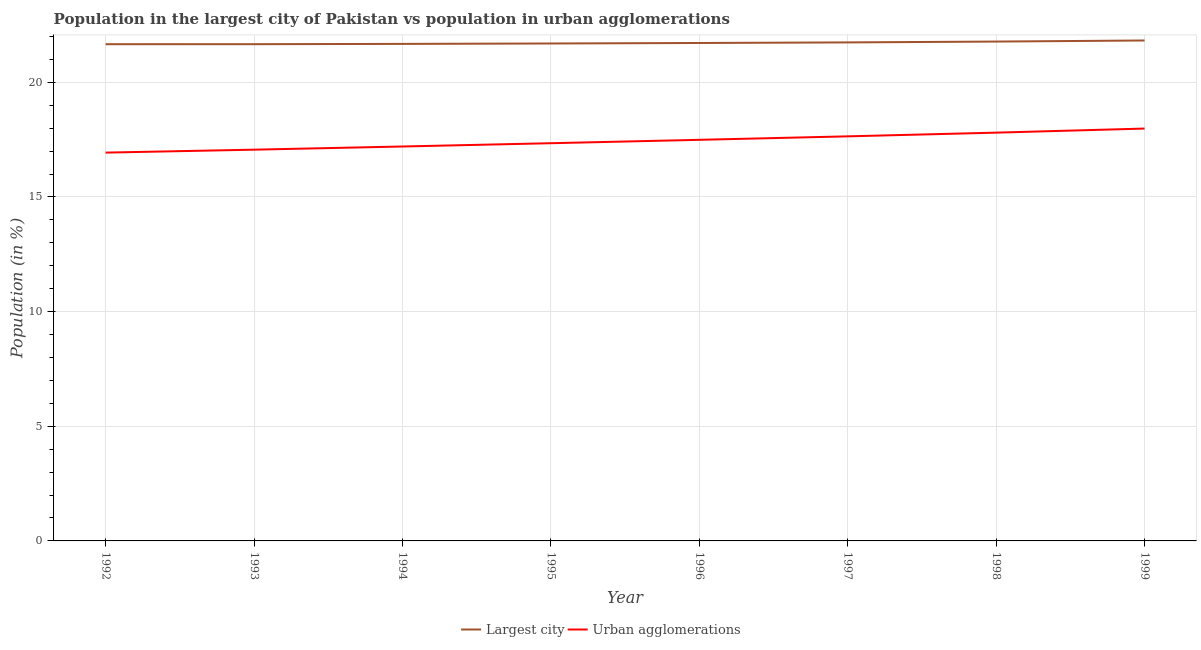What is the population in urban agglomerations in 1996?
Your answer should be compact. 17.49. Across all years, what is the maximum population in urban agglomerations?
Provide a succinct answer. 17.98. Across all years, what is the minimum population in the largest city?
Your answer should be very brief. 21.66. In which year was the population in the largest city maximum?
Give a very brief answer. 1999. In which year was the population in the largest city minimum?
Your answer should be very brief. 1992. What is the total population in urban agglomerations in the graph?
Offer a terse response. 139.47. What is the difference between the population in urban agglomerations in 1992 and that in 1998?
Provide a short and direct response. -0.87. What is the difference between the population in the largest city in 1999 and the population in urban agglomerations in 1992?
Provide a short and direct response. 4.89. What is the average population in urban agglomerations per year?
Give a very brief answer. 17.43. In the year 1993, what is the difference between the population in urban agglomerations and population in the largest city?
Offer a very short reply. -4.6. What is the ratio of the population in urban agglomerations in 1992 to that in 1995?
Offer a terse response. 0.98. Is the difference between the population in urban agglomerations in 1992 and 1995 greater than the difference between the population in the largest city in 1992 and 1995?
Ensure brevity in your answer.  No. What is the difference between the highest and the second highest population in the largest city?
Your answer should be compact. 0.05. What is the difference between the highest and the lowest population in urban agglomerations?
Keep it short and to the point. 1.05. Is the population in the largest city strictly less than the population in urban agglomerations over the years?
Give a very brief answer. No. What is the difference between two consecutive major ticks on the Y-axis?
Offer a terse response. 5. Are the values on the major ticks of Y-axis written in scientific E-notation?
Your answer should be very brief. No. Does the graph contain any zero values?
Give a very brief answer. No. Does the graph contain grids?
Provide a succinct answer. Yes. Where does the legend appear in the graph?
Ensure brevity in your answer.  Bottom center. How many legend labels are there?
Offer a very short reply. 2. What is the title of the graph?
Make the answer very short. Population in the largest city of Pakistan vs population in urban agglomerations. What is the label or title of the X-axis?
Your answer should be very brief. Year. What is the label or title of the Y-axis?
Keep it short and to the point. Population (in %). What is the Population (in %) of Largest city in 1992?
Your answer should be compact. 21.66. What is the Population (in %) of Urban agglomerations in 1992?
Keep it short and to the point. 16.94. What is the Population (in %) of Largest city in 1993?
Ensure brevity in your answer.  21.66. What is the Population (in %) in Urban agglomerations in 1993?
Ensure brevity in your answer.  17.06. What is the Population (in %) in Largest city in 1994?
Provide a short and direct response. 21.68. What is the Population (in %) of Urban agglomerations in 1994?
Give a very brief answer. 17.2. What is the Population (in %) in Largest city in 1995?
Provide a short and direct response. 21.69. What is the Population (in %) in Urban agglomerations in 1995?
Offer a very short reply. 17.35. What is the Population (in %) of Largest city in 1996?
Make the answer very short. 21.72. What is the Population (in %) of Urban agglomerations in 1996?
Make the answer very short. 17.49. What is the Population (in %) of Largest city in 1997?
Offer a terse response. 21.74. What is the Population (in %) of Urban agglomerations in 1997?
Give a very brief answer. 17.64. What is the Population (in %) in Largest city in 1998?
Make the answer very short. 21.78. What is the Population (in %) of Urban agglomerations in 1998?
Offer a terse response. 17.81. What is the Population (in %) in Largest city in 1999?
Your response must be concise. 21.83. What is the Population (in %) of Urban agglomerations in 1999?
Make the answer very short. 17.98. Across all years, what is the maximum Population (in %) in Largest city?
Your answer should be very brief. 21.83. Across all years, what is the maximum Population (in %) of Urban agglomerations?
Your answer should be very brief. 17.98. Across all years, what is the minimum Population (in %) in Largest city?
Offer a terse response. 21.66. Across all years, what is the minimum Population (in %) in Urban agglomerations?
Ensure brevity in your answer.  16.94. What is the total Population (in %) of Largest city in the graph?
Provide a short and direct response. 173.76. What is the total Population (in %) in Urban agglomerations in the graph?
Your answer should be compact. 139.47. What is the difference between the Population (in %) of Largest city in 1992 and that in 1993?
Offer a terse response. -0. What is the difference between the Population (in %) of Urban agglomerations in 1992 and that in 1993?
Ensure brevity in your answer.  -0.13. What is the difference between the Population (in %) in Largest city in 1992 and that in 1994?
Ensure brevity in your answer.  -0.01. What is the difference between the Population (in %) in Urban agglomerations in 1992 and that in 1994?
Make the answer very short. -0.27. What is the difference between the Population (in %) in Largest city in 1992 and that in 1995?
Keep it short and to the point. -0.03. What is the difference between the Population (in %) of Urban agglomerations in 1992 and that in 1995?
Your answer should be very brief. -0.41. What is the difference between the Population (in %) of Largest city in 1992 and that in 1996?
Provide a succinct answer. -0.05. What is the difference between the Population (in %) in Urban agglomerations in 1992 and that in 1996?
Ensure brevity in your answer.  -0.56. What is the difference between the Population (in %) in Largest city in 1992 and that in 1997?
Your response must be concise. -0.08. What is the difference between the Population (in %) of Urban agglomerations in 1992 and that in 1997?
Provide a short and direct response. -0.71. What is the difference between the Population (in %) of Largest city in 1992 and that in 1998?
Ensure brevity in your answer.  -0.12. What is the difference between the Population (in %) in Urban agglomerations in 1992 and that in 1998?
Ensure brevity in your answer.  -0.87. What is the difference between the Population (in %) in Largest city in 1992 and that in 1999?
Keep it short and to the point. -0.16. What is the difference between the Population (in %) in Urban agglomerations in 1992 and that in 1999?
Your answer should be compact. -1.05. What is the difference between the Population (in %) of Largest city in 1993 and that in 1994?
Your answer should be compact. -0.01. What is the difference between the Population (in %) of Urban agglomerations in 1993 and that in 1994?
Your answer should be compact. -0.14. What is the difference between the Population (in %) in Largest city in 1993 and that in 1995?
Your response must be concise. -0.03. What is the difference between the Population (in %) of Urban agglomerations in 1993 and that in 1995?
Your answer should be compact. -0.28. What is the difference between the Population (in %) in Largest city in 1993 and that in 1996?
Offer a terse response. -0.05. What is the difference between the Population (in %) of Urban agglomerations in 1993 and that in 1996?
Ensure brevity in your answer.  -0.43. What is the difference between the Population (in %) of Largest city in 1993 and that in 1997?
Provide a succinct answer. -0.08. What is the difference between the Population (in %) of Urban agglomerations in 1993 and that in 1997?
Your answer should be compact. -0.58. What is the difference between the Population (in %) of Largest city in 1993 and that in 1998?
Offer a terse response. -0.11. What is the difference between the Population (in %) of Urban agglomerations in 1993 and that in 1998?
Give a very brief answer. -0.74. What is the difference between the Population (in %) of Largest city in 1993 and that in 1999?
Give a very brief answer. -0.16. What is the difference between the Population (in %) in Urban agglomerations in 1993 and that in 1999?
Keep it short and to the point. -0.92. What is the difference between the Population (in %) of Largest city in 1994 and that in 1995?
Provide a succinct answer. -0.02. What is the difference between the Population (in %) in Urban agglomerations in 1994 and that in 1995?
Make the answer very short. -0.14. What is the difference between the Population (in %) of Largest city in 1994 and that in 1996?
Provide a short and direct response. -0.04. What is the difference between the Population (in %) of Urban agglomerations in 1994 and that in 1996?
Your answer should be compact. -0.29. What is the difference between the Population (in %) in Largest city in 1994 and that in 1997?
Offer a terse response. -0.07. What is the difference between the Population (in %) of Urban agglomerations in 1994 and that in 1997?
Your answer should be very brief. -0.44. What is the difference between the Population (in %) of Largest city in 1994 and that in 1998?
Offer a very short reply. -0.1. What is the difference between the Population (in %) in Urban agglomerations in 1994 and that in 1998?
Provide a short and direct response. -0.6. What is the difference between the Population (in %) in Largest city in 1994 and that in 1999?
Your answer should be very brief. -0.15. What is the difference between the Population (in %) in Urban agglomerations in 1994 and that in 1999?
Keep it short and to the point. -0.78. What is the difference between the Population (in %) in Largest city in 1995 and that in 1996?
Give a very brief answer. -0.02. What is the difference between the Population (in %) in Urban agglomerations in 1995 and that in 1996?
Offer a very short reply. -0.15. What is the difference between the Population (in %) of Largest city in 1995 and that in 1997?
Offer a very short reply. -0.05. What is the difference between the Population (in %) in Urban agglomerations in 1995 and that in 1997?
Make the answer very short. -0.3. What is the difference between the Population (in %) in Largest city in 1995 and that in 1998?
Your answer should be compact. -0.08. What is the difference between the Population (in %) in Urban agglomerations in 1995 and that in 1998?
Offer a terse response. -0.46. What is the difference between the Population (in %) of Largest city in 1995 and that in 1999?
Your response must be concise. -0.13. What is the difference between the Population (in %) in Urban agglomerations in 1995 and that in 1999?
Make the answer very short. -0.64. What is the difference between the Population (in %) of Largest city in 1996 and that in 1997?
Ensure brevity in your answer.  -0.03. What is the difference between the Population (in %) of Urban agglomerations in 1996 and that in 1997?
Your answer should be very brief. -0.15. What is the difference between the Population (in %) of Largest city in 1996 and that in 1998?
Give a very brief answer. -0.06. What is the difference between the Population (in %) of Urban agglomerations in 1996 and that in 1998?
Offer a very short reply. -0.31. What is the difference between the Population (in %) of Largest city in 1996 and that in 1999?
Give a very brief answer. -0.11. What is the difference between the Population (in %) of Urban agglomerations in 1996 and that in 1999?
Offer a very short reply. -0.49. What is the difference between the Population (in %) of Largest city in 1997 and that in 1998?
Provide a short and direct response. -0.04. What is the difference between the Population (in %) in Urban agglomerations in 1997 and that in 1998?
Provide a short and direct response. -0.16. What is the difference between the Population (in %) of Largest city in 1997 and that in 1999?
Give a very brief answer. -0.08. What is the difference between the Population (in %) in Urban agglomerations in 1997 and that in 1999?
Provide a succinct answer. -0.34. What is the difference between the Population (in %) in Largest city in 1998 and that in 1999?
Make the answer very short. -0.05. What is the difference between the Population (in %) in Urban agglomerations in 1998 and that in 1999?
Give a very brief answer. -0.18. What is the difference between the Population (in %) in Largest city in 1992 and the Population (in %) in Urban agglomerations in 1993?
Offer a terse response. 4.6. What is the difference between the Population (in %) of Largest city in 1992 and the Population (in %) of Urban agglomerations in 1994?
Keep it short and to the point. 4.46. What is the difference between the Population (in %) in Largest city in 1992 and the Population (in %) in Urban agglomerations in 1995?
Offer a very short reply. 4.32. What is the difference between the Population (in %) of Largest city in 1992 and the Population (in %) of Urban agglomerations in 1996?
Your response must be concise. 4.17. What is the difference between the Population (in %) of Largest city in 1992 and the Population (in %) of Urban agglomerations in 1997?
Make the answer very short. 4.02. What is the difference between the Population (in %) of Largest city in 1992 and the Population (in %) of Urban agglomerations in 1998?
Provide a succinct answer. 3.86. What is the difference between the Population (in %) in Largest city in 1992 and the Population (in %) in Urban agglomerations in 1999?
Your answer should be very brief. 3.68. What is the difference between the Population (in %) of Largest city in 1993 and the Population (in %) of Urban agglomerations in 1994?
Your answer should be very brief. 4.46. What is the difference between the Population (in %) in Largest city in 1993 and the Population (in %) in Urban agglomerations in 1995?
Give a very brief answer. 4.32. What is the difference between the Population (in %) in Largest city in 1993 and the Population (in %) in Urban agglomerations in 1996?
Ensure brevity in your answer.  4.17. What is the difference between the Population (in %) in Largest city in 1993 and the Population (in %) in Urban agglomerations in 1997?
Provide a short and direct response. 4.02. What is the difference between the Population (in %) of Largest city in 1993 and the Population (in %) of Urban agglomerations in 1998?
Your response must be concise. 3.86. What is the difference between the Population (in %) of Largest city in 1993 and the Population (in %) of Urban agglomerations in 1999?
Your response must be concise. 3.68. What is the difference between the Population (in %) of Largest city in 1994 and the Population (in %) of Urban agglomerations in 1995?
Keep it short and to the point. 4.33. What is the difference between the Population (in %) in Largest city in 1994 and the Population (in %) in Urban agglomerations in 1996?
Give a very brief answer. 4.18. What is the difference between the Population (in %) of Largest city in 1994 and the Population (in %) of Urban agglomerations in 1997?
Provide a succinct answer. 4.03. What is the difference between the Population (in %) of Largest city in 1994 and the Population (in %) of Urban agglomerations in 1998?
Offer a terse response. 3.87. What is the difference between the Population (in %) in Largest city in 1994 and the Population (in %) in Urban agglomerations in 1999?
Make the answer very short. 3.69. What is the difference between the Population (in %) of Largest city in 1995 and the Population (in %) of Urban agglomerations in 1996?
Give a very brief answer. 4.2. What is the difference between the Population (in %) in Largest city in 1995 and the Population (in %) in Urban agglomerations in 1997?
Your response must be concise. 4.05. What is the difference between the Population (in %) of Largest city in 1995 and the Population (in %) of Urban agglomerations in 1998?
Your answer should be very brief. 3.89. What is the difference between the Population (in %) in Largest city in 1995 and the Population (in %) in Urban agglomerations in 1999?
Your answer should be compact. 3.71. What is the difference between the Population (in %) in Largest city in 1996 and the Population (in %) in Urban agglomerations in 1997?
Your response must be concise. 4.07. What is the difference between the Population (in %) of Largest city in 1996 and the Population (in %) of Urban agglomerations in 1998?
Offer a very short reply. 3.91. What is the difference between the Population (in %) of Largest city in 1996 and the Population (in %) of Urban agglomerations in 1999?
Provide a short and direct response. 3.73. What is the difference between the Population (in %) in Largest city in 1997 and the Population (in %) in Urban agglomerations in 1998?
Ensure brevity in your answer.  3.94. What is the difference between the Population (in %) in Largest city in 1997 and the Population (in %) in Urban agglomerations in 1999?
Make the answer very short. 3.76. What is the difference between the Population (in %) in Largest city in 1998 and the Population (in %) in Urban agglomerations in 1999?
Offer a very short reply. 3.79. What is the average Population (in %) of Largest city per year?
Make the answer very short. 21.72. What is the average Population (in %) of Urban agglomerations per year?
Keep it short and to the point. 17.43. In the year 1992, what is the difference between the Population (in %) of Largest city and Population (in %) of Urban agglomerations?
Your answer should be very brief. 4.73. In the year 1993, what is the difference between the Population (in %) of Largest city and Population (in %) of Urban agglomerations?
Give a very brief answer. 4.6. In the year 1994, what is the difference between the Population (in %) of Largest city and Population (in %) of Urban agglomerations?
Your answer should be very brief. 4.47. In the year 1995, what is the difference between the Population (in %) of Largest city and Population (in %) of Urban agglomerations?
Your answer should be very brief. 4.35. In the year 1996, what is the difference between the Population (in %) in Largest city and Population (in %) in Urban agglomerations?
Your answer should be very brief. 4.22. In the year 1997, what is the difference between the Population (in %) of Largest city and Population (in %) of Urban agglomerations?
Your answer should be very brief. 4.1. In the year 1998, what is the difference between the Population (in %) of Largest city and Population (in %) of Urban agglomerations?
Your answer should be compact. 3.97. In the year 1999, what is the difference between the Population (in %) in Largest city and Population (in %) in Urban agglomerations?
Your answer should be compact. 3.84. What is the ratio of the Population (in %) of Largest city in 1992 to that in 1993?
Keep it short and to the point. 1. What is the ratio of the Population (in %) of Urban agglomerations in 1992 to that in 1993?
Offer a very short reply. 0.99. What is the ratio of the Population (in %) of Largest city in 1992 to that in 1994?
Ensure brevity in your answer.  1. What is the ratio of the Population (in %) of Urban agglomerations in 1992 to that in 1994?
Your answer should be compact. 0.98. What is the ratio of the Population (in %) in Urban agglomerations in 1992 to that in 1995?
Keep it short and to the point. 0.98. What is the ratio of the Population (in %) in Largest city in 1992 to that in 1996?
Your answer should be very brief. 1. What is the ratio of the Population (in %) in Urban agglomerations in 1992 to that in 1996?
Make the answer very short. 0.97. What is the ratio of the Population (in %) in Urban agglomerations in 1992 to that in 1997?
Offer a very short reply. 0.96. What is the ratio of the Population (in %) in Largest city in 1992 to that in 1998?
Make the answer very short. 0.99. What is the ratio of the Population (in %) in Urban agglomerations in 1992 to that in 1998?
Ensure brevity in your answer.  0.95. What is the ratio of the Population (in %) of Urban agglomerations in 1992 to that in 1999?
Your answer should be compact. 0.94. What is the ratio of the Population (in %) of Urban agglomerations in 1993 to that in 1995?
Ensure brevity in your answer.  0.98. What is the ratio of the Population (in %) of Urban agglomerations in 1993 to that in 1996?
Your answer should be very brief. 0.98. What is the ratio of the Population (in %) of Largest city in 1993 to that in 1997?
Offer a terse response. 1. What is the ratio of the Population (in %) of Urban agglomerations in 1993 to that in 1997?
Your answer should be very brief. 0.97. What is the ratio of the Population (in %) in Urban agglomerations in 1993 to that in 1998?
Keep it short and to the point. 0.96. What is the ratio of the Population (in %) in Urban agglomerations in 1993 to that in 1999?
Your answer should be compact. 0.95. What is the ratio of the Population (in %) of Largest city in 1994 to that in 1995?
Your answer should be compact. 1. What is the ratio of the Population (in %) in Urban agglomerations in 1994 to that in 1995?
Provide a short and direct response. 0.99. What is the ratio of the Population (in %) of Largest city in 1994 to that in 1996?
Offer a very short reply. 1. What is the ratio of the Population (in %) of Urban agglomerations in 1994 to that in 1996?
Offer a very short reply. 0.98. What is the ratio of the Population (in %) in Urban agglomerations in 1994 to that in 1997?
Offer a terse response. 0.97. What is the ratio of the Population (in %) in Urban agglomerations in 1994 to that in 1998?
Offer a terse response. 0.97. What is the ratio of the Population (in %) in Urban agglomerations in 1994 to that in 1999?
Offer a very short reply. 0.96. What is the ratio of the Population (in %) of Largest city in 1995 to that in 1996?
Your answer should be very brief. 1. What is the ratio of the Population (in %) in Urban agglomerations in 1995 to that in 1998?
Your answer should be compact. 0.97. What is the ratio of the Population (in %) of Largest city in 1995 to that in 1999?
Offer a very short reply. 0.99. What is the ratio of the Population (in %) in Urban agglomerations in 1995 to that in 1999?
Offer a terse response. 0.96. What is the ratio of the Population (in %) in Urban agglomerations in 1996 to that in 1997?
Make the answer very short. 0.99. What is the ratio of the Population (in %) of Largest city in 1996 to that in 1998?
Make the answer very short. 1. What is the ratio of the Population (in %) of Urban agglomerations in 1996 to that in 1998?
Your answer should be very brief. 0.98. What is the ratio of the Population (in %) of Urban agglomerations in 1996 to that in 1999?
Your response must be concise. 0.97. What is the ratio of the Population (in %) in Largest city in 1997 to that in 1998?
Offer a very short reply. 1. What is the ratio of the Population (in %) in Urban agglomerations in 1997 to that in 1998?
Provide a succinct answer. 0.99. What is the ratio of the Population (in %) of Urban agglomerations in 1997 to that in 1999?
Keep it short and to the point. 0.98. What is the ratio of the Population (in %) in Urban agglomerations in 1998 to that in 1999?
Keep it short and to the point. 0.99. What is the difference between the highest and the second highest Population (in %) of Largest city?
Give a very brief answer. 0.05. What is the difference between the highest and the second highest Population (in %) of Urban agglomerations?
Your response must be concise. 0.18. What is the difference between the highest and the lowest Population (in %) in Largest city?
Provide a short and direct response. 0.16. What is the difference between the highest and the lowest Population (in %) in Urban agglomerations?
Make the answer very short. 1.05. 